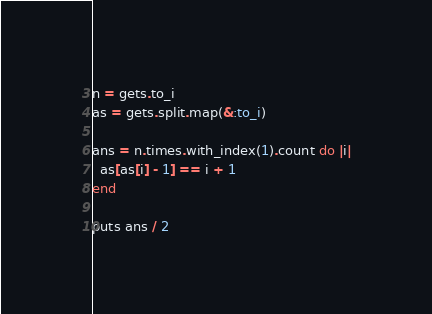Convert code to text. <code><loc_0><loc_0><loc_500><loc_500><_Ruby_>n = gets.to_i
as = gets.split.map(&:to_i)

ans = n.times.with_index(1).count do |i|
  as[as[i] - 1] == i + 1
end

puts ans / 2
</code> 